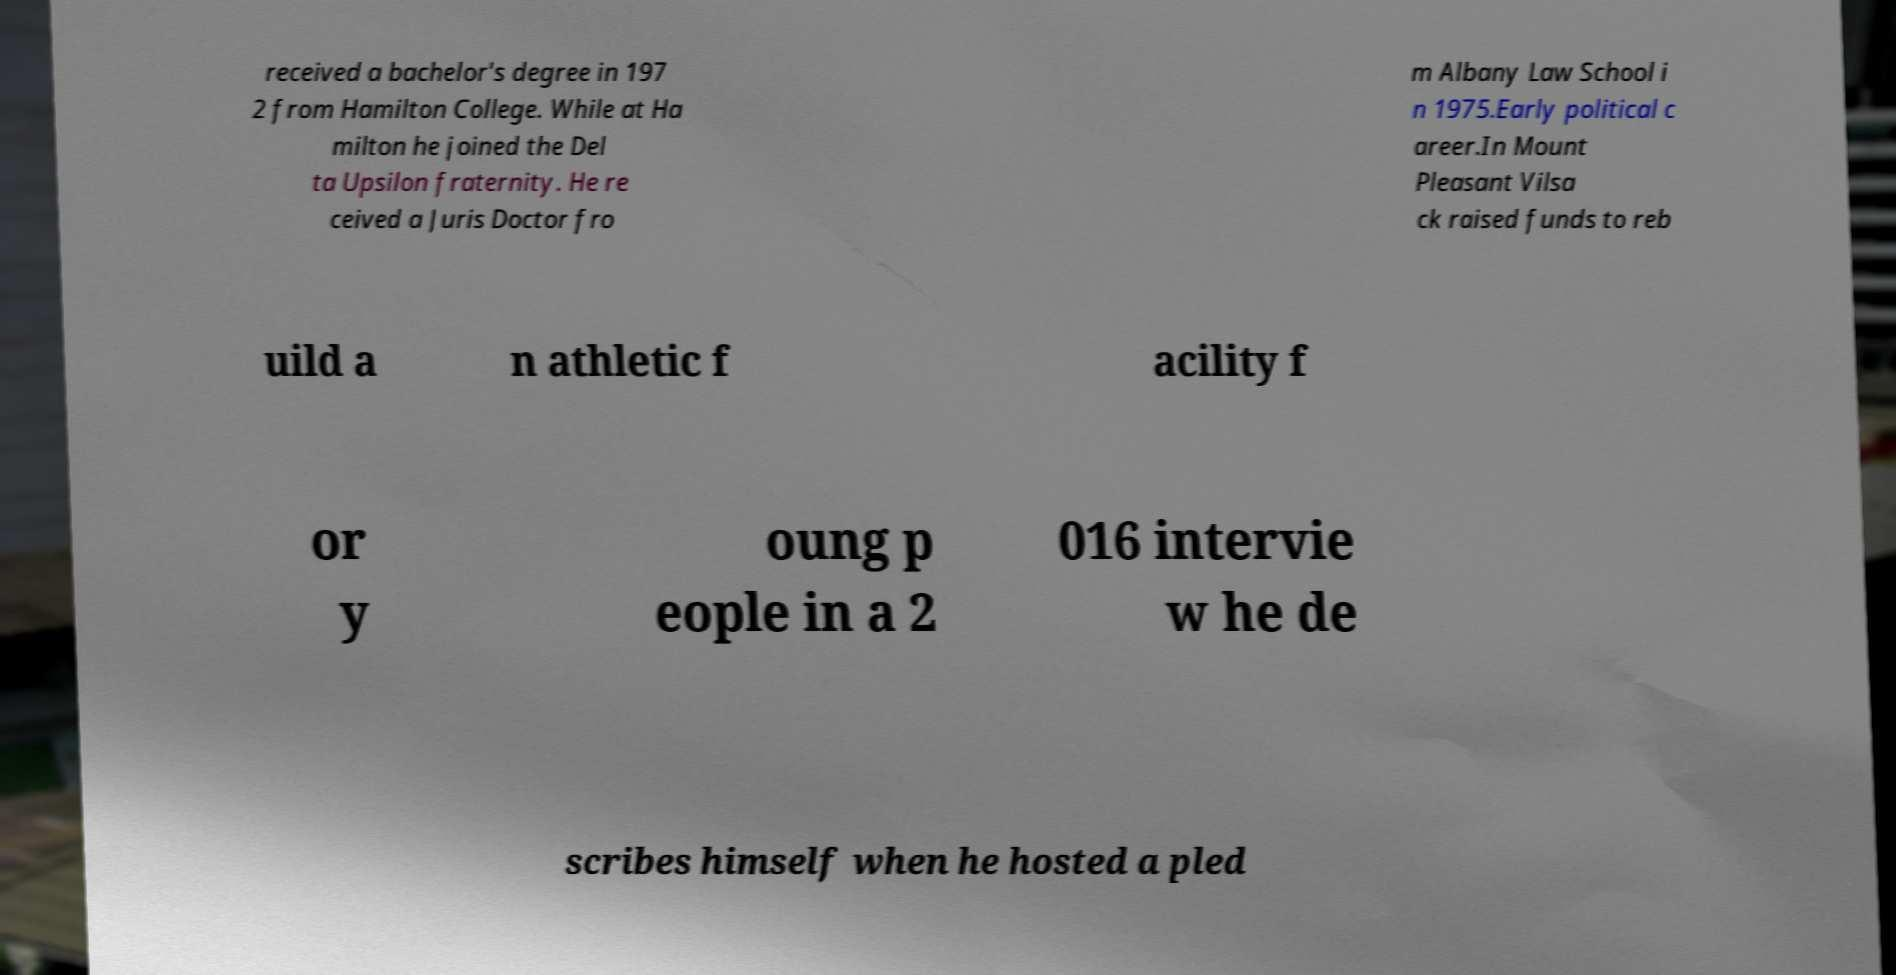Please read and relay the text visible in this image. What does it say? received a bachelor's degree in 197 2 from Hamilton College. While at Ha milton he joined the Del ta Upsilon fraternity. He re ceived a Juris Doctor fro m Albany Law School i n 1975.Early political c areer.In Mount Pleasant Vilsa ck raised funds to reb uild a n athletic f acility f or y oung p eople in a 2 016 intervie w he de scribes himself when he hosted a pled 